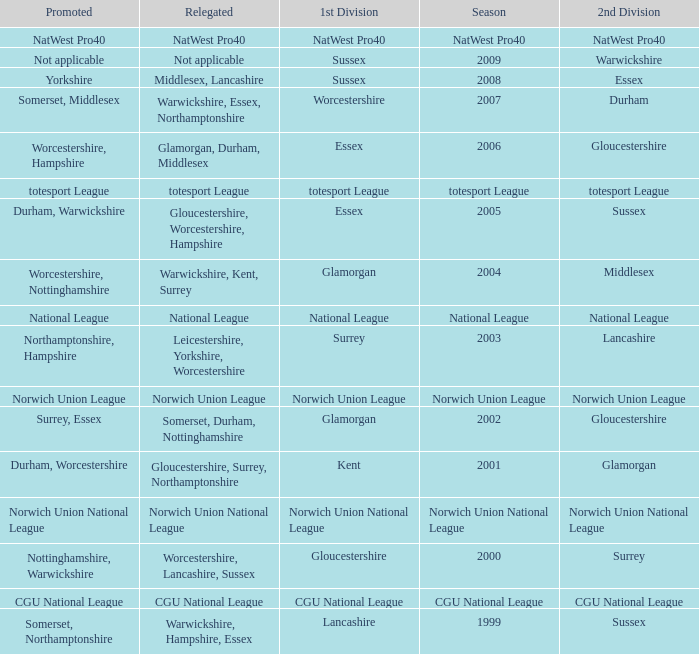What was relegated in the 2nd division of middlesex? Warwickshire, Kent, Surrey. 